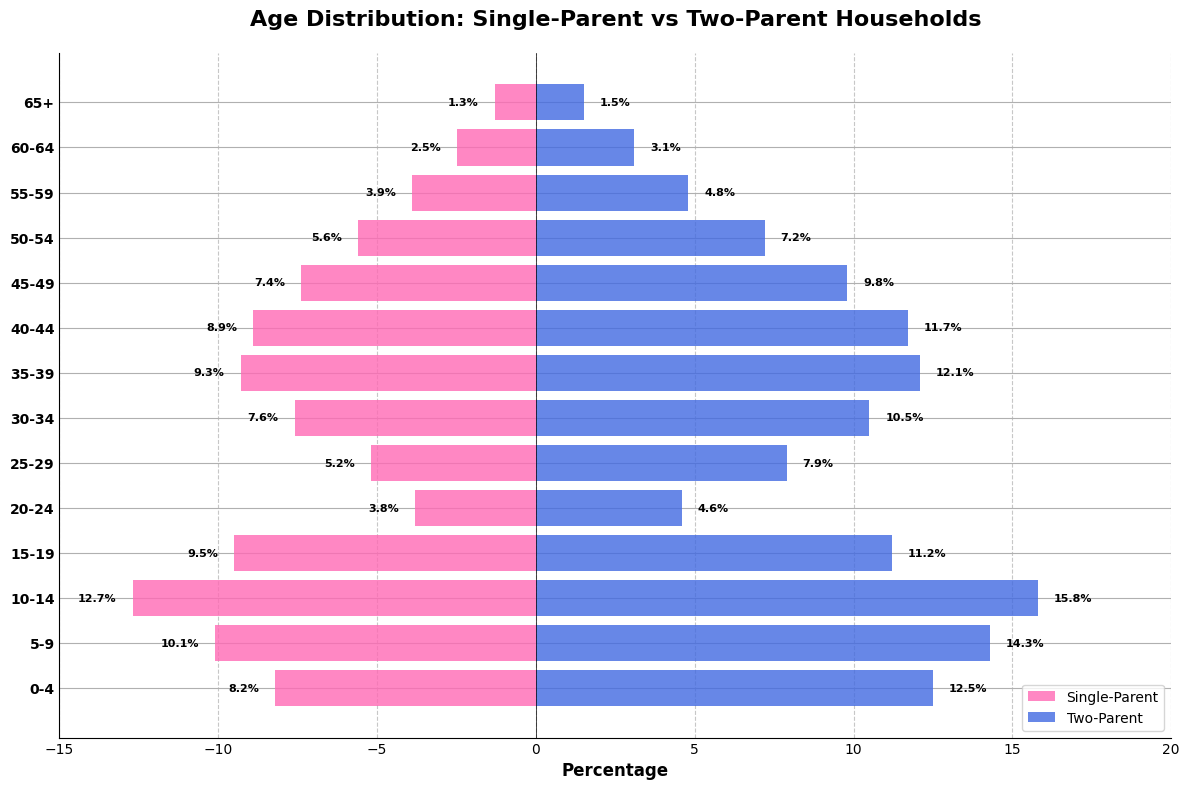What's the title of the figure? The title is displayed at the top of the figure, it reads 'Age Distribution: Single-Parent vs Two-Parent Households'.
Answer: Age Distribution: Single-Parent vs Two-Parent Households Which age group has the highest percentage of single-parent households? The graph shows the highest percentage bar for single-parent households in the age group 10-14.
Answer: 10-14 What is the percentage of two-parent households in the 0-4 age group? Refer to the length of the blue bar corresponding to the 0-4 age group, which is 12.5%.
Answer: 12.5% For the 15-19 age group, how do single-parent and two-parent households compare? Compare the lengths of the pink bar (single-parent) and blue bar (two-parent) for the 15-19 age group; single-parent is -9.5% and two-parent is 11.2%.
Answer: Single-parent: 9.5%, Two-parent: 11.2% Which household type has a higher percentage for the age group 45-49? For the age group 45-49, the blue bar (two-parent) is longer compared to the pink bar (single-parent).
Answer: Two-parent How many data points are shown on the y-axis? Count the number of labels on the y-axis, which represent the age groups. There are 14 age groups listed.
Answer: 14 Across all age groups, which type of household consistently has higher percentages? By comparing the lengths of the pink (single-parent) and blue (two-parent) bars across all age groups, it is evident that two-parent households consistently have higher percentages.
Answer: Two-parent Which age group shows the smallest percentage difference between single-parent and two-parent households? The percentages for the 65+ age group are -1.3% (single-parent) and 1.5% (two-parent). The difference is smallest at 1.5 - 1.3 = 0.2.
Answer: 65+ 